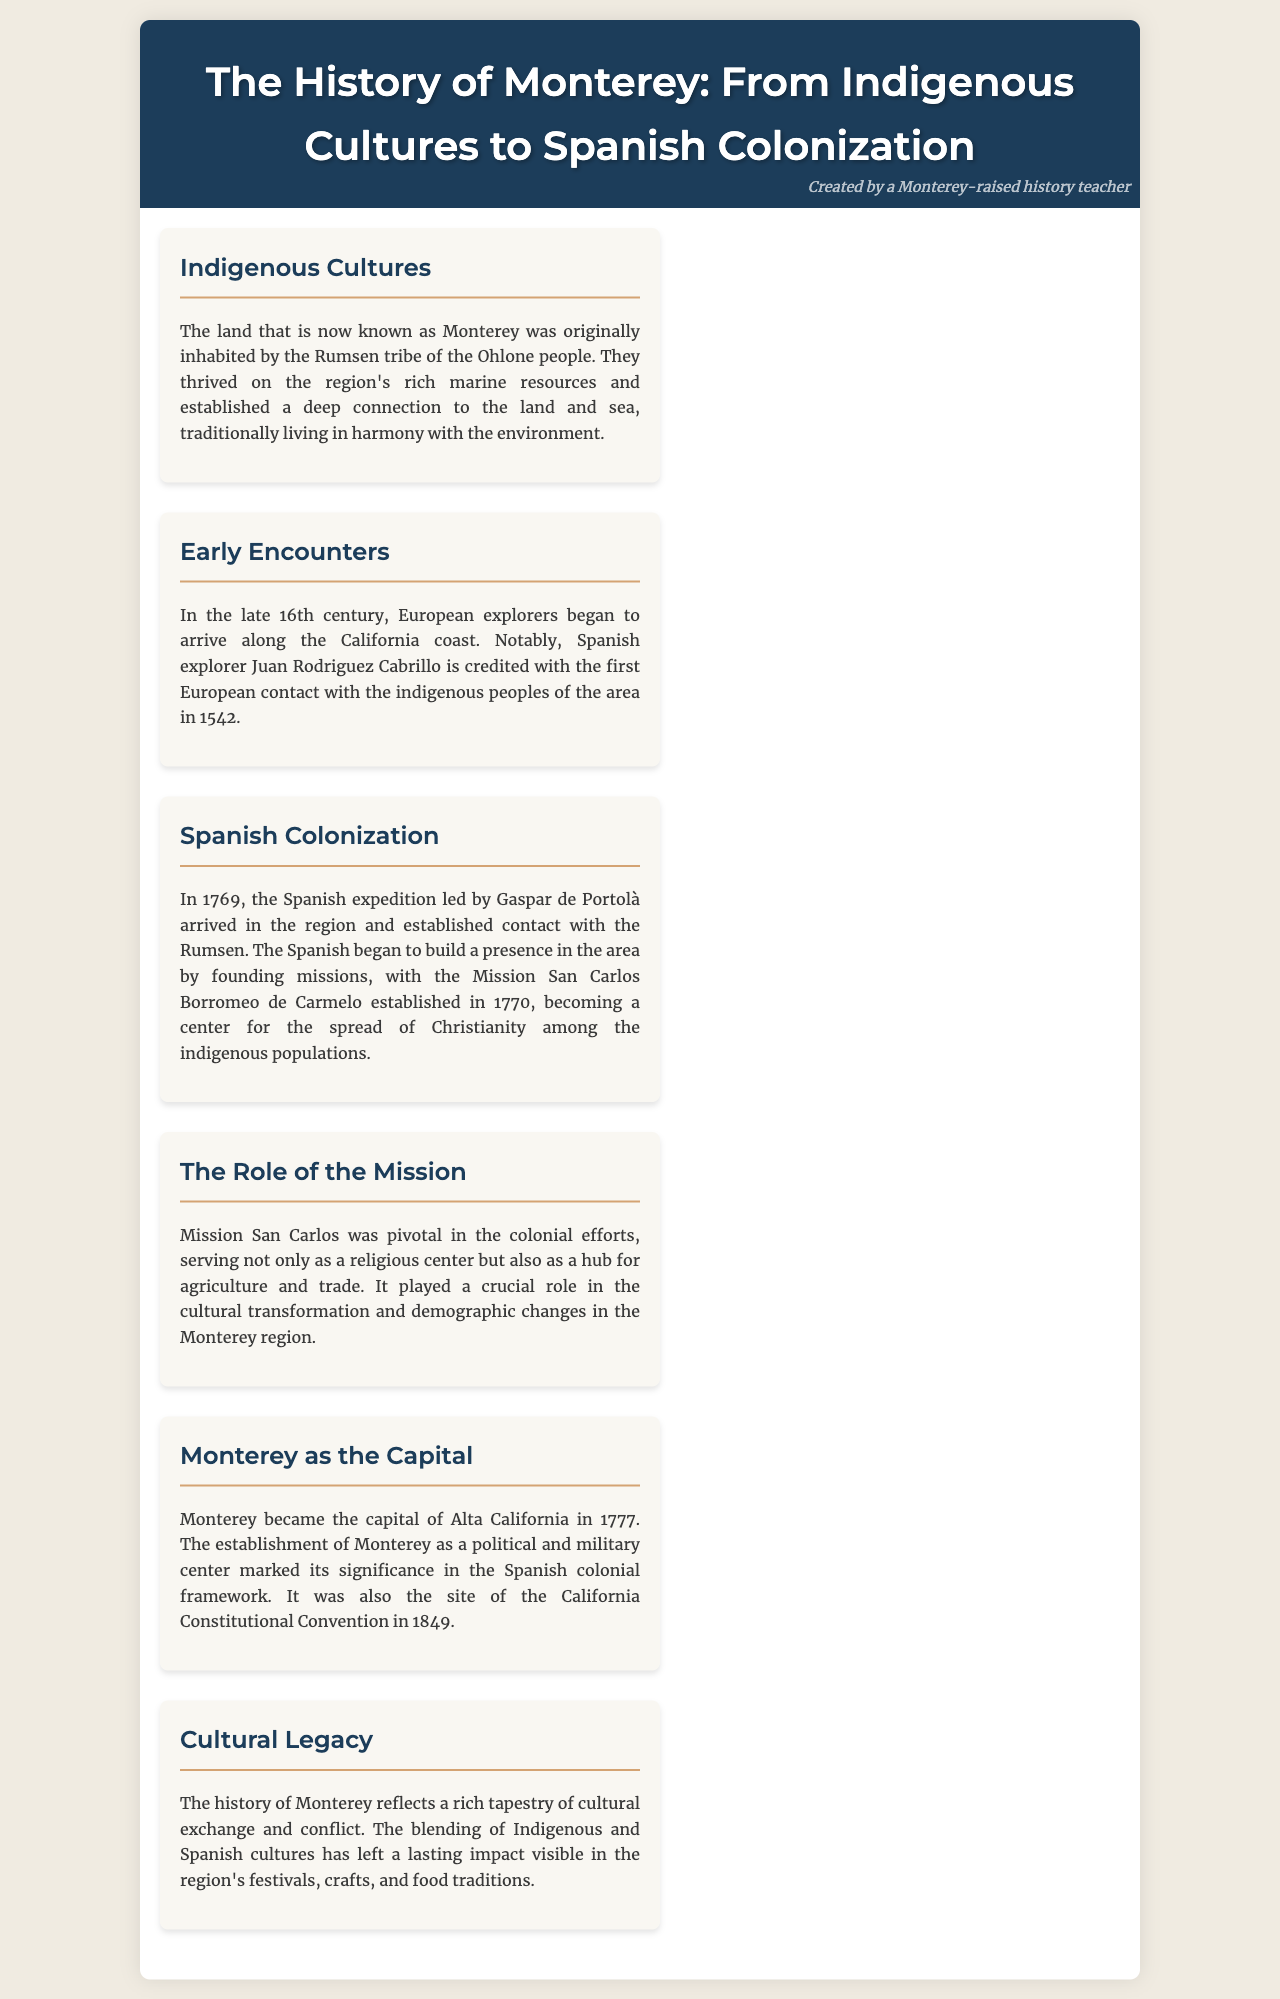What tribe originally inhabited Monterey? The document states that the land was originally inhabited by the Rumsen tribe of the Ohlone people.
Answer: Rumsen Who established the first European contact with indigenous peoples in Monterey? According to the document, Spanish explorer Juan Rodriguez Cabrillo is credited with the first European contact in 1542.
Answer: Juan Rodriguez Cabrillo In what year was Mission San Carlos Borromeo de Carmelo established? The document specifies that Mission San Carlos was established in the year 1770.
Answer: 1770 What significant role did Mission San Carlos play? The brochure describes Mission San Carlos as serving as a religious center and a hub for agriculture and trade.
Answer: Religious center, agriculture and trade hub When did Monterey become the capital of Alta California? The document notes that Monterey became the capital of Alta California in 1777.
Answer: 1777 What event took place in Monterey in 1849? The brochure highlights that the California Constitutional Convention took place in Monterey in 1849.
Answer: California Constitutional Convention What impact did the blending of Indigenous and Spanish cultures have in Monterey? The document mentions that the blending of these cultures has left a lasting impact visible in festivals, crafts, and food traditions.
Answer: Festivals, crafts, and food traditions What is the overall theme of the history presented in the document? The brochure reflects a rich tapestry of cultural exchange and conflict in the Monterey region's history.
Answer: Cultural exchange and conflict 